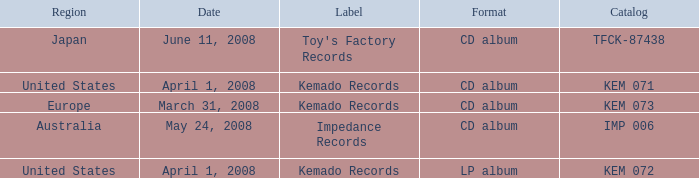Which Region has a Format of cd album, and a Label of kemado records, and a Catalog of kem 071? United States. 